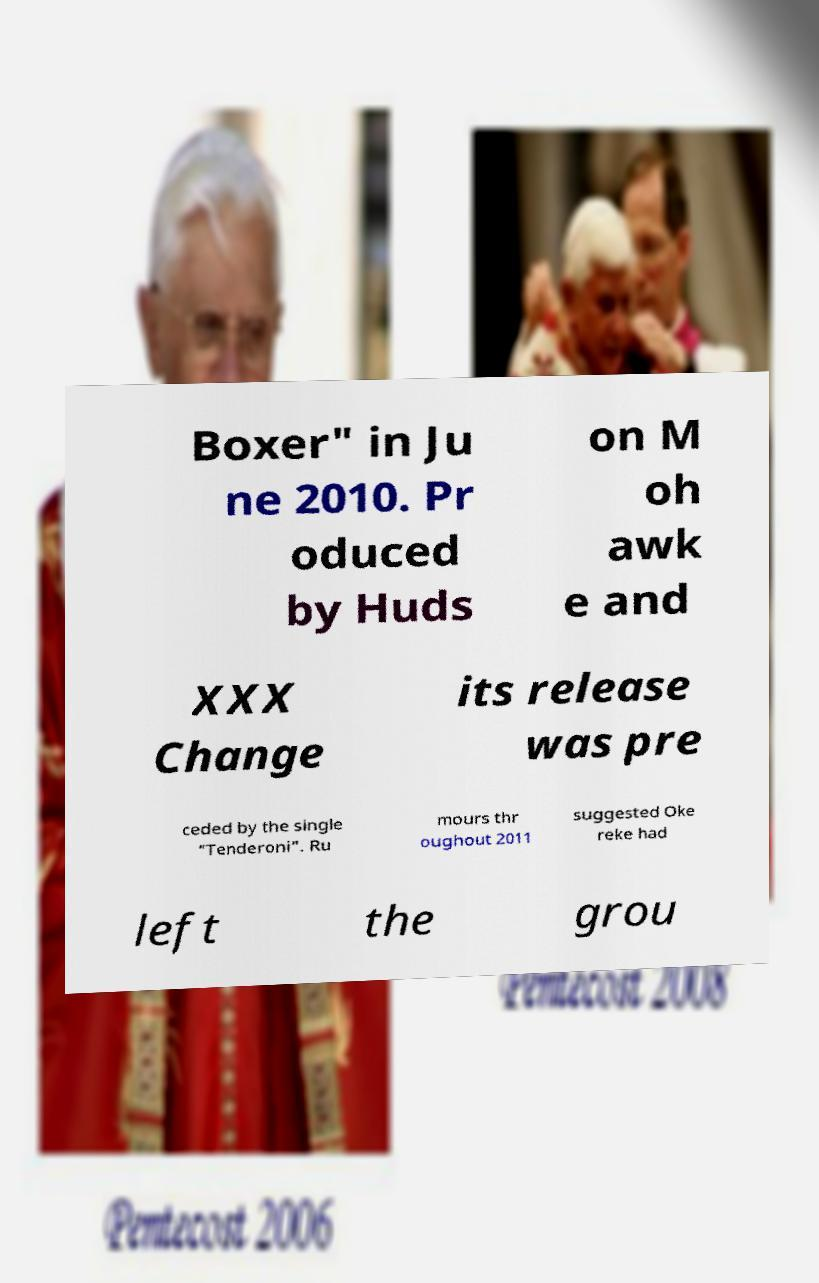There's text embedded in this image that I need extracted. Can you transcribe it verbatim? Boxer" in Ju ne 2010. Pr oduced by Huds on M oh awk e and XXX Change its release was pre ceded by the single "Tenderoni". Ru mours thr oughout 2011 suggested Oke reke had left the grou 